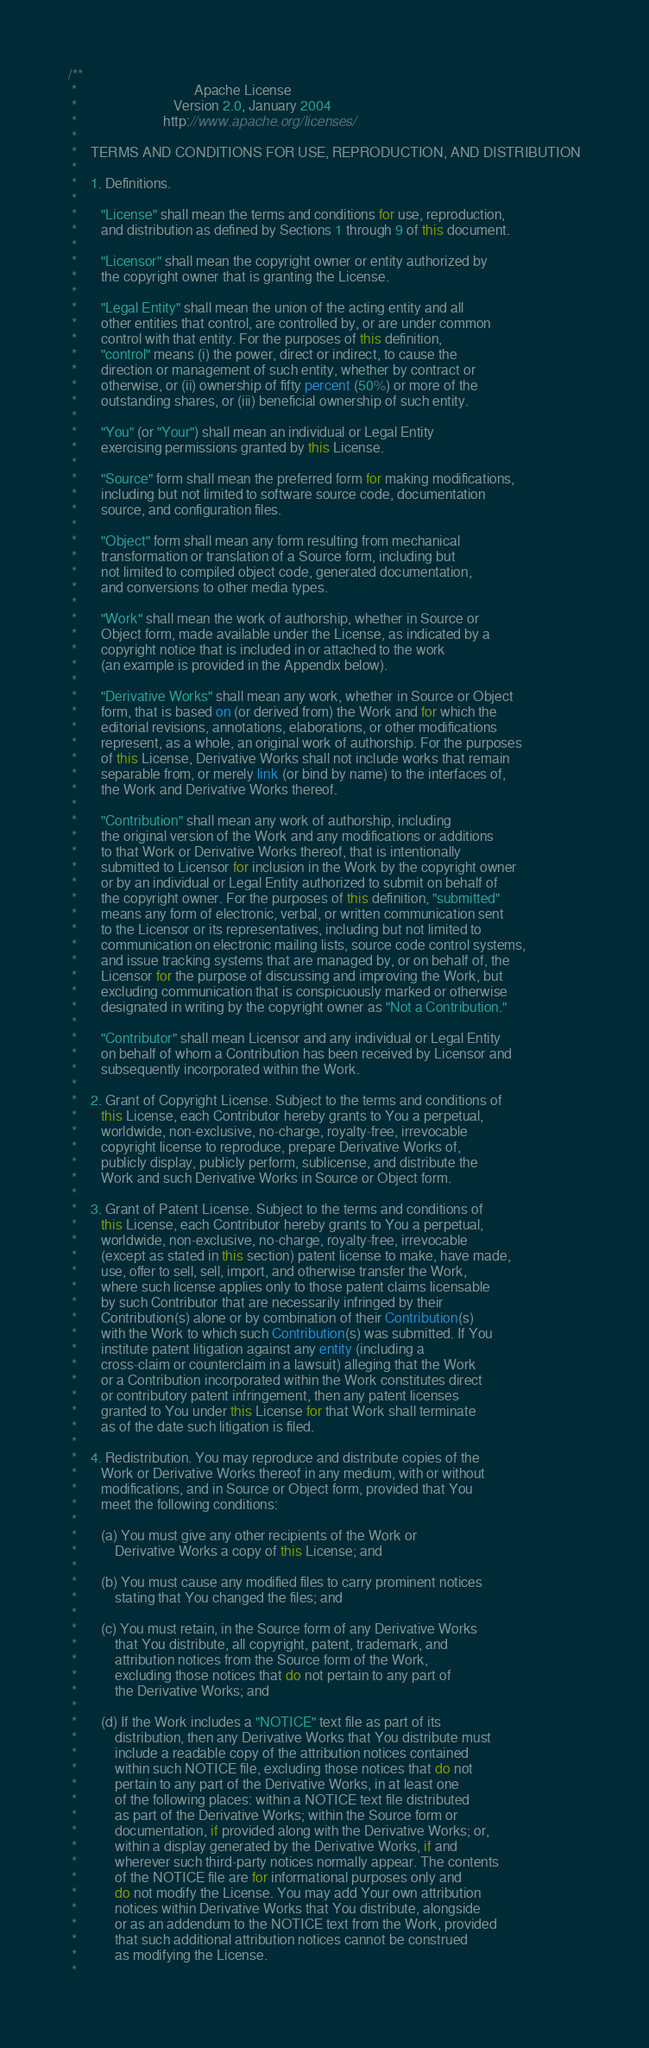Convert code to text. <code><loc_0><loc_0><loc_500><loc_500><_Java_>/**
 *                                  Apache License
 *                            Version 2.0, January 2004
 *                         http://www.apache.org/licenses/
 *
 *    TERMS AND CONDITIONS FOR USE, REPRODUCTION, AND DISTRIBUTION
 *
 *    1. Definitions.
 *
 *       "License" shall mean the terms and conditions for use, reproduction,
 *       and distribution as defined by Sections 1 through 9 of this document.
 *
 *       "Licensor" shall mean the copyright owner or entity authorized by
 *       the copyright owner that is granting the License.
 *
 *       "Legal Entity" shall mean the union of the acting entity and all
 *       other entities that control, are controlled by, or are under common
 *       control with that entity. For the purposes of this definition,
 *       "control" means (i) the power, direct or indirect, to cause the
 *       direction or management of such entity, whether by contract or
 *       otherwise, or (ii) ownership of fifty percent (50%) or more of the
 *       outstanding shares, or (iii) beneficial ownership of such entity.
 *
 *       "You" (or "Your") shall mean an individual or Legal Entity
 *       exercising permissions granted by this License.
 *
 *       "Source" form shall mean the preferred form for making modifications,
 *       including but not limited to software source code, documentation
 *       source, and configuration files.
 *
 *       "Object" form shall mean any form resulting from mechanical
 *       transformation or translation of a Source form, including but
 *       not limited to compiled object code, generated documentation,
 *       and conversions to other media types.
 *
 *       "Work" shall mean the work of authorship, whether in Source or
 *       Object form, made available under the License, as indicated by a
 *       copyright notice that is included in or attached to the work
 *       (an example is provided in the Appendix below).
 *
 *       "Derivative Works" shall mean any work, whether in Source or Object
 *       form, that is based on (or derived from) the Work and for which the
 *       editorial revisions, annotations, elaborations, or other modifications
 *       represent, as a whole, an original work of authorship. For the purposes
 *       of this License, Derivative Works shall not include works that remain
 *       separable from, or merely link (or bind by name) to the interfaces of,
 *       the Work and Derivative Works thereof.
 *
 *       "Contribution" shall mean any work of authorship, including
 *       the original version of the Work and any modifications or additions
 *       to that Work or Derivative Works thereof, that is intentionally
 *       submitted to Licensor for inclusion in the Work by the copyright owner
 *       or by an individual or Legal Entity authorized to submit on behalf of
 *       the copyright owner. For the purposes of this definition, "submitted"
 *       means any form of electronic, verbal, or written communication sent
 *       to the Licensor or its representatives, including but not limited to
 *       communication on electronic mailing lists, source code control systems,
 *       and issue tracking systems that are managed by, or on behalf of, the
 *       Licensor for the purpose of discussing and improving the Work, but
 *       excluding communication that is conspicuously marked or otherwise
 *       designated in writing by the copyright owner as "Not a Contribution."
 *
 *       "Contributor" shall mean Licensor and any individual or Legal Entity
 *       on behalf of whom a Contribution has been received by Licensor and
 *       subsequently incorporated within the Work.
 *
 *    2. Grant of Copyright License. Subject to the terms and conditions of
 *       this License, each Contributor hereby grants to You a perpetual,
 *       worldwide, non-exclusive, no-charge, royalty-free, irrevocable
 *       copyright license to reproduce, prepare Derivative Works of,
 *       publicly display, publicly perform, sublicense, and distribute the
 *       Work and such Derivative Works in Source or Object form.
 *
 *    3. Grant of Patent License. Subject to the terms and conditions of
 *       this License, each Contributor hereby grants to You a perpetual,
 *       worldwide, non-exclusive, no-charge, royalty-free, irrevocable
 *       (except as stated in this section) patent license to make, have made,
 *       use, offer to sell, sell, import, and otherwise transfer the Work,
 *       where such license applies only to those patent claims licensable
 *       by such Contributor that are necessarily infringed by their
 *       Contribution(s) alone or by combination of their Contribution(s)
 *       with the Work to which such Contribution(s) was submitted. If You
 *       institute patent litigation against any entity (including a
 *       cross-claim or counterclaim in a lawsuit) alleging that the Work
 *       or a Contribution incorporated within the Work constitutes direct
 *       or contributory patent infringement, then any patent licenses
 *       granted to You under this License for that Work shall terminate
 *       as of the date such litigation is filed.
 *
 *    4. Redistribution. You may reproduce and distribute copies of the
 *       Work or Derivative Works thereof in any medium, with or without
 *       modifications, and in Source or Object form, provided that You
 *       meet the following conditions:
 *
 *       (a) You must give any other recipients of the Work or
 *           Derivative Works a copy of this License; and
 *
 *       (b) You must cause any modified files to carry prominent notices
 *           stating that You changed the files; and
 *
 *       (c) You must retain, in the Source form of any Derivative Works
 *           that You distribute, all copyright, patent, trademark, and
 *           attribution notices from the Source form of the Work,
 *           excluding those notices that do not pertain to any part of
 *           the Derivative Works; and
 *
 *       (d) If the Work includes a "NOTICE" text file as part of its
 *           distribution, then any Derivative Works that You distribute must
 *           include a readable copy of the attribution notices contained
 *           within such NOTICE file, excluding those notices that do not
 *           pertain to any part of the Derivative Works, in at least one
 *           of the following places: within a NOTICE text file distributed
 *           as part of the Derivative Works; within the Source form or
 *           documentation, if provided along with the Derivative Works; or,
 *           within a display generated by the Derivative Works, if and
 *           wherever such third-party notices normally appear. The contents
 *           of the NOTICE file are for informational purposes only and
 *           do not modify the License. You may add Your own attribution
 *           notices within Derivative Works that You distribute, alongside
 *           or as an addendum to the NOTICE text from the Work, provided
 *           that such additional attribution notices cannot be construed
 *           as modifying the License.
 *</code> 